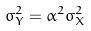<formula> <loc_0><loc_0><loc_500><loc_500>\sigma _ { Y } ^ { 2 } = \alpha ^ { 2 } \sigma _ { X } ^ { 2 }</formula> 